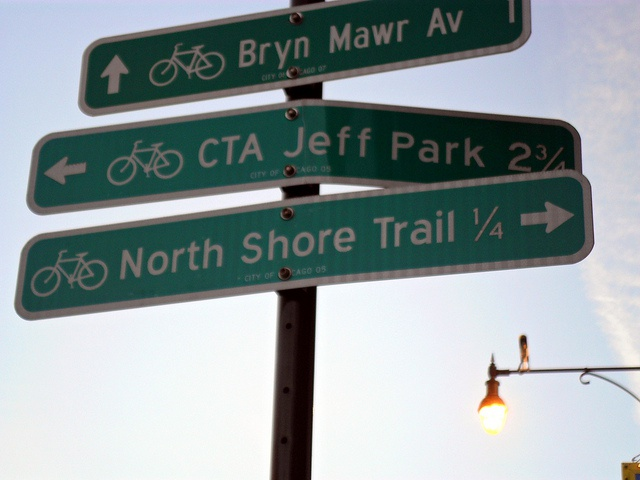Describe the objects in this image and their specific colors. I can see various objects in this image with different colors. 